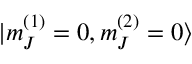Convert formula to latex. <formula><loc_0><loc_0><loc_500><loc_500>| m _ { J } ^ { ( 1 ) } = 0 , m _ { J } ^ { ( 2 ) } = 0 \rangle</formula> 